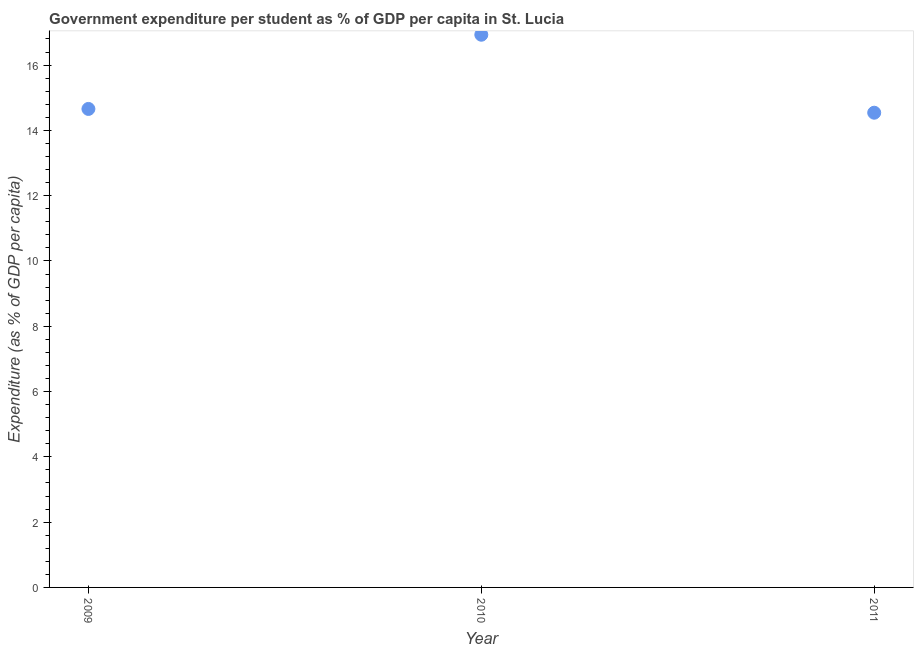What is the government expenditure per student in 2010?
Ensure brevity in your answer.  16.93. Across all years, what is the maximum government expenditure per student?
Ensure brevity in your answer.  16.93. Across all years, what is the minimum government expenditure per student?
Offer a very short reply. 14.54. In which year was the government expenditure per student minimum?
Make the answer very short. 2011. What is the sum of the government expenditure per student?
Your answer should be compact. 46.13. What is the difference between the government expenditure per student in 2010 and 2011?
Ensure brevity in your answer.  2.39. What is the average government expenditure per student per year?
Your answer should be compact. 15.38. What is the median government expenditure per student?
Ensure brevity in your answer.  14.66. In how many years, is the government expenditure per student greater than 12.4 %?
Give a very brief answer. 3. Do a majority of the years between 2009 and 2011 (inclusive) have government expenditure per student greater than 10 %?
Your response must be concise. Yes. What is the ratio of the government expenditure per student in 2010 to that in 2011?
Make the answer very short. 1.16. Is the government expenditure per student in 2009 less than that in 2010?
Ensure brevity in your answer.  Yes. Is the difference between the government expenditure per student in 2010 and 2011 greater than the difference between any two years?
Offer a very short reply. Yes. What is the difference between the highest and the second highest government expenditure per student?
Give a very brief answer. 2.27. Is the sum of the government expenditure per student in 2009 and 2011 greater than the maximum government expenditure per student across all years?
Give a very brief answer. Yes. What is the difference between the highest and the lowest government expenditure per student?
Your answer should be very brief. 2.39. In how many years, is the government expenditure per student greater than the average government expenditure per student taken over all years?
Give a very brief answer. 1. How many dotlines are there?
Give a very brief answer. 1. How many years are there in the graph?
Provide a succinct answer. 3. Are the values on the major ticks of Y-axis written in scientific E-notation?
Give a very brief answer. No. What is the title of the graph?
Your response must be concise. Government expenditure per student as % of GDP per capita in St. Lucia. What is the label or title of the X-axis?
Offer a very short reply. Year. What is the label or title of the Y-axis?
Give a very brief answer. Expenditure (as % of GDP per capita). What is the Expenditure (as % of GDP per capita) in 2009?
Provide a succinct answer. 14.66. What is the Expenditure (as % of GDP per capita) in 2010?
Provide a succinct answer. 16.93. What is the Expenditure (as % of GDP per capita) in 2011?
Make the answer very short. 14.54. What is the difference between the Expenditure (as % of GDP per capita) in 2009 and 2010?
Offer a very short reply. -2.27. What is the difference between the Expenditure (as % of GDP per capita) in 2009 and 2011?
Your answer should be very brief. 0.12. What is the difference between the Expenditure (as % of GDP per capita) in 2010 and 2011?
Offer a terse response. 2.39. What is the ratio of the Expenditure (as % of GDP per capita) in 2009 to that in 2010?
Make the answer very short. 0.87. What is the ratio of the Expenditure (as % of GDP per capita) in 2010 to that in 2011?
Provide a short and direct response. 1.16. 